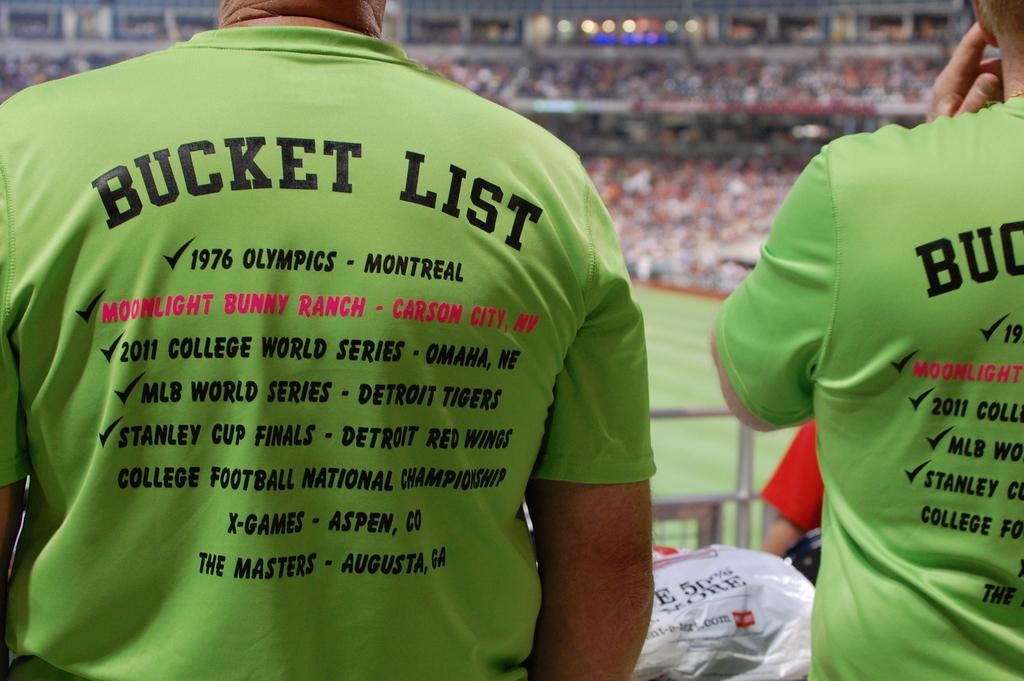<image>
Give a short and clear explanation of the subsequent image. A person is at a sports stadium wearing a shirt that says "bucket list" on the back. 